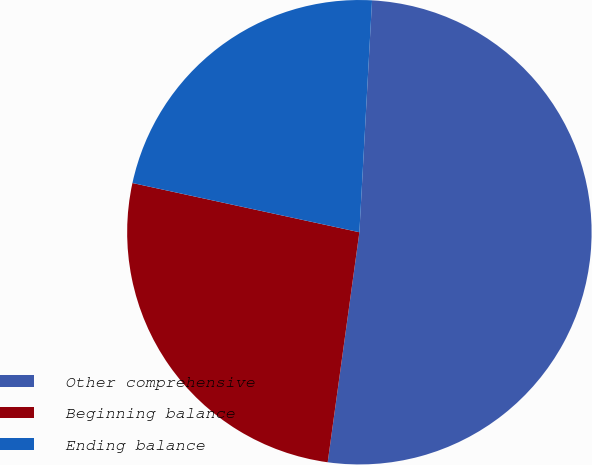Convert chart. <chart><loc_0><loc_0><loc_500><loc_500><pie_chart><fcel>Other comprehensive<fcel>Beginning balance<fcel>Ending balance<nl><fcel>51.31%<fcel>26.22%<fcel>22.47%<nl></chart> 